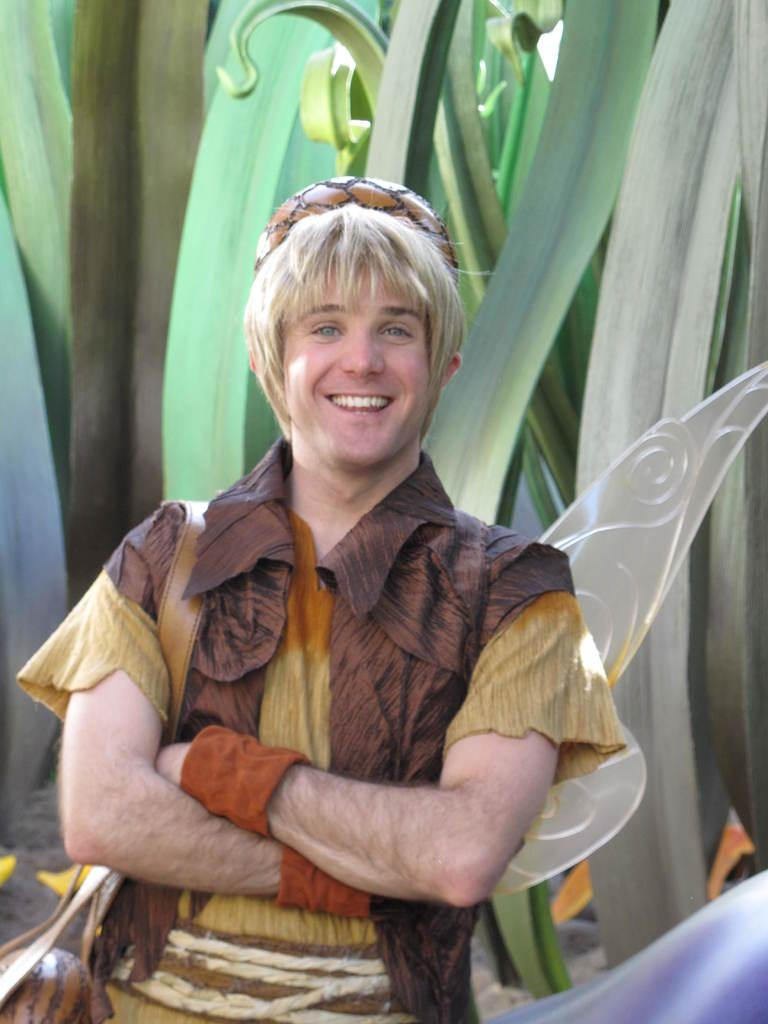What is the main subject in the image? There is a man standing in the image. Can you describe anything on the wall in the image? There is a picture of plants on a wall in the image. How many planes can be seen flying in the image? There are no planes visible in the image. What type of finger is the man using to hold the wall in the image? The man is not holding the wall in the image, and there is no mention of fingers. 